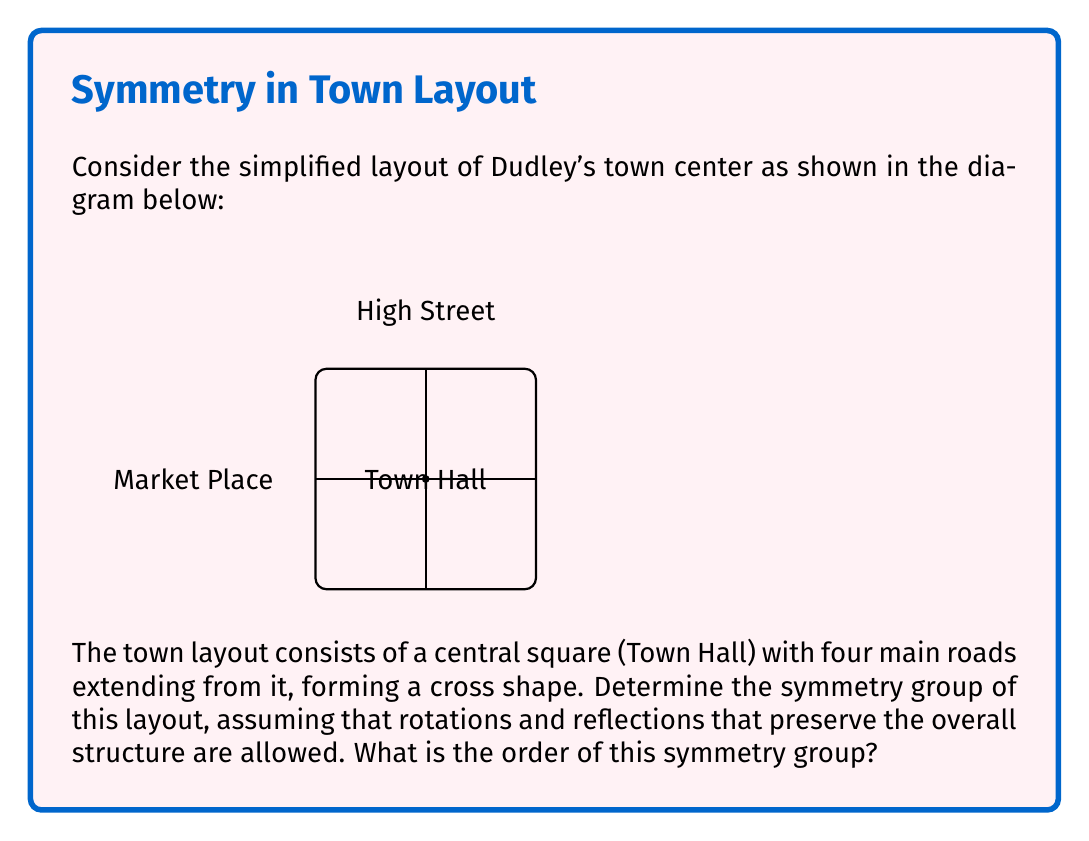Solve this math problem. To determine the symmetry group of Dudley's town layout, we need to consider all the transformations that leave the structure unchanged. Let's analyze this step-by-step:

1) Rotations:
   - The layout allows for rotations of 0°, 90°, 180°, and 270° around the Town Hall.
   - This gives us 4 rotational symmetries.

2) Reflections:
   - There are two lines of reflection: one along High Street and one along Market Place.
   - This gives us 2 reflection symmetries.

3) Identity:
   - The identity transformation (doing nothing) is always a symmetry.
   - This is already counted in the rotations (0° rotation).

Now, let's identify the symmetry group:

- The group has 8 elements in total (4 rotations and 4 reflections, including the identity).
- It has rotations of order 4 and reflections.
- This structure matches the dihedral group of order 8, denoted as $D_4$ or $D_8$ (depending on the notation system).

The elements of $D_4$ can be represented as:
$$D_4 = \{e, r, r^2, r^3, s, sr, sr^2, sr^3\}$$

Where:
- $e$ is the identity
- $r$ is a 90° rotation
- $s$ is a reflection

The group operation table for $D_4$ would show how these elements combine.

Therefore, the symmetry group of Dudley's town layout is isomorphic to the dihedral group $D_4$, and its order is 8.
Answer: $D_4$, order 8 